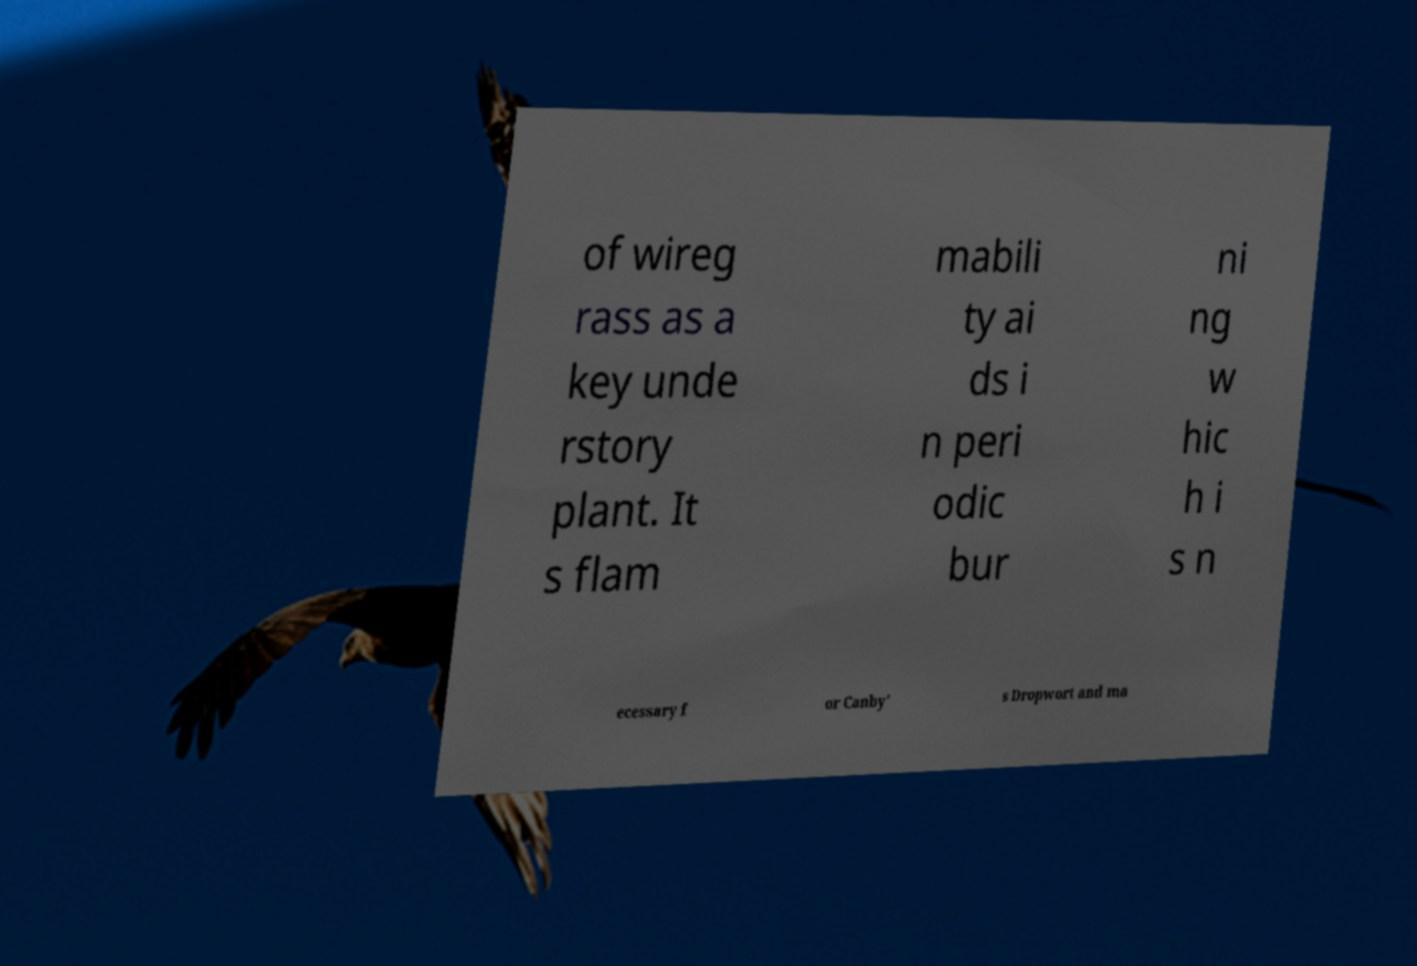Could you extract and type out the text from this image? of wireg rass as a key unde rstory plant. It s flam mabili ty ai ds i n peri odic bur ni ng w hic h i s n ecessary f or Canby' s Dropwort and ma 